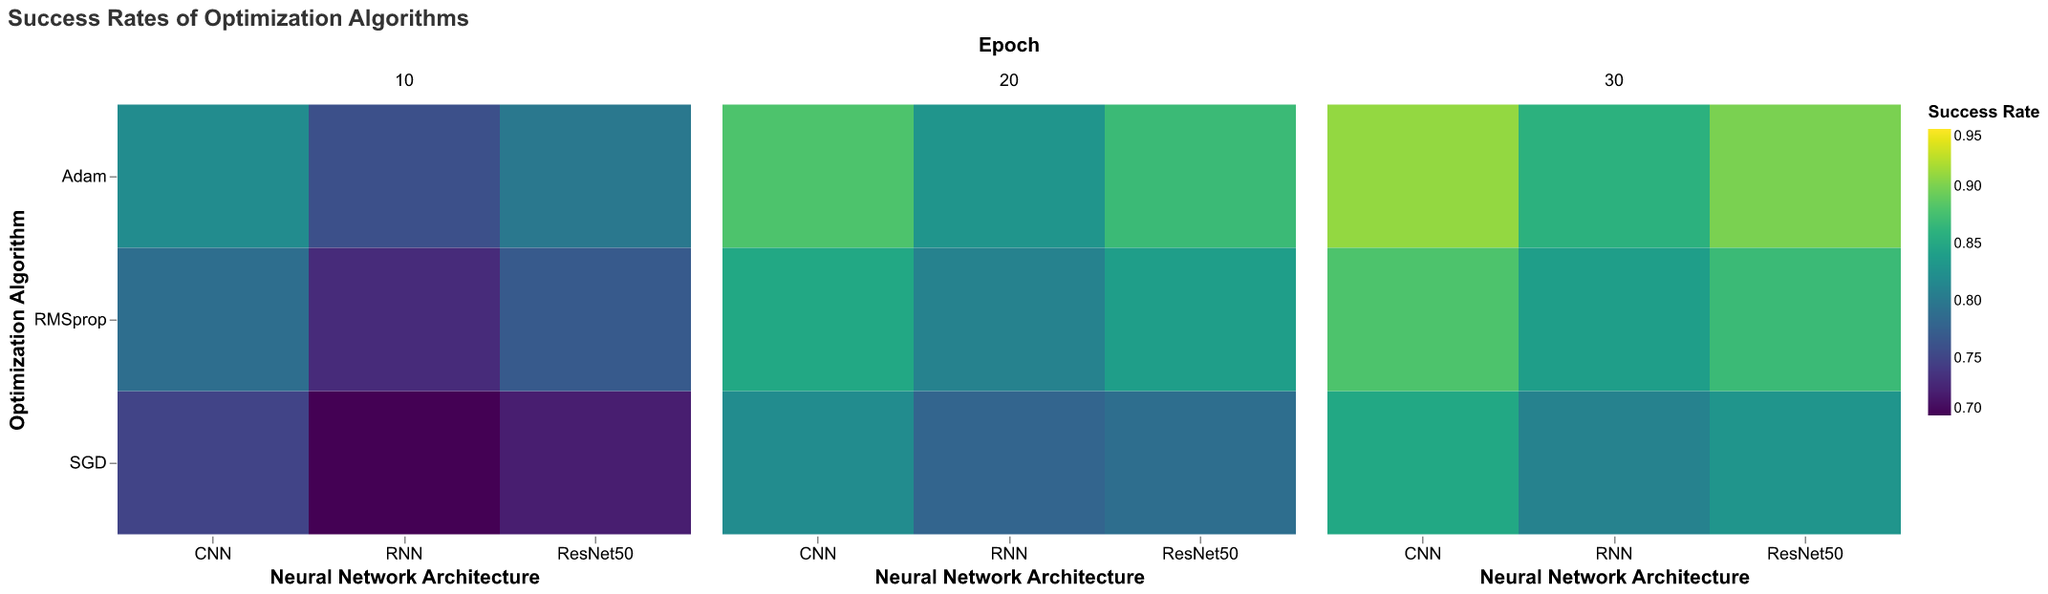What is the title of the heatmap? The title is usually located at the top of the figure. In this case, it reads "Success Rates of Optimization Algorithms."
Answer: Success Rates of Optimization Algorithms Which algorithm has the highest success rate for the CNN architecture at 30 epochs? To find the highest success rate for CNN at 30 epochs, we look along the column labeled "CNN" in the faceted plot for 30 epochs. Adam has a success rate of 0.91, which is the highest.
Answer: Adam Which architecture has the lowest success rate with the SGD algorithm at 10 epochs? We look at the row labeled "SGD" and find the 10 epochs plot. Among CNN, RNN, and ResNet50, RNN has the lowest success rate of 0.70.
Answer: RNN What is the range of the success rates shown in the heatmap? The color scale legend indicates the range of possible success rates. Here, it ranges from 0.70 to 0.95.
Answer: 0.70 to 0.95 Compare the success rate of RMSprop and Adam for the ResNet50 architecture at 20 epochs. Which has a higher rate and by how much? Locate the ResNet50 column for 20 epochs. RMSprop has a success rate of 0.84, while Adam has 0.87. Adam's rate is higher by 0.03.
Answer: Adam by 0.03 How does the success rate of the algorithms change from 10 to 30 epochs for the RNN architecture? Examine the RNN column across different epochs for each algorithm. Adam increases from 0.76 to 0.86, SGD from 0.70 to 0.81, and RMSprop from 0.73 to 0.84. All show an increase.
Answer: It increases for all algorithms Which combination of algorithm and architecture achieves exactly a 0.80 success rate at any epoch? Look through each cell for the success rate of 0.80. Adam with ResNet50 at 10 epochs matches this rate.
Answer: Adam with ResNet50 at 10 epochs Which epoch shows the highest success rate overall, and for which algorithm and architecture combination does this occur? Scan all values across epochs. The highest visible success rate is 0.91, which occurs at 30 epochs for Adam with CNN.
Answer: 30 epochs for Adam with CNN 